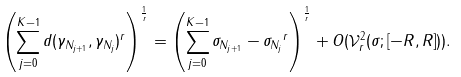Convert formula to latex. <formula><loc_0><loc_0><loc_500><loc_500>\left ( \sum _ { j = 0 } ^ { K - 1 } d ( \gamma _ { N _ { j + 1 } } , \gamma _ { N _ { j } } ) ^ { r } \right ) ^ { \frac { 1 } { r } } = \left ( \sum _ { j = 0 } ^ { K - 1 } \| \sigma _ { N _ { j + 1 } } - \sigma _ { N _ { j } } \| ^ { r } \right ) ^ { \frac { 1 } { r } } + O ( \mathcal { V } ^ { 2 } _ { r } ( \sigma ; [ - R , R ] ) ) .</formula> 